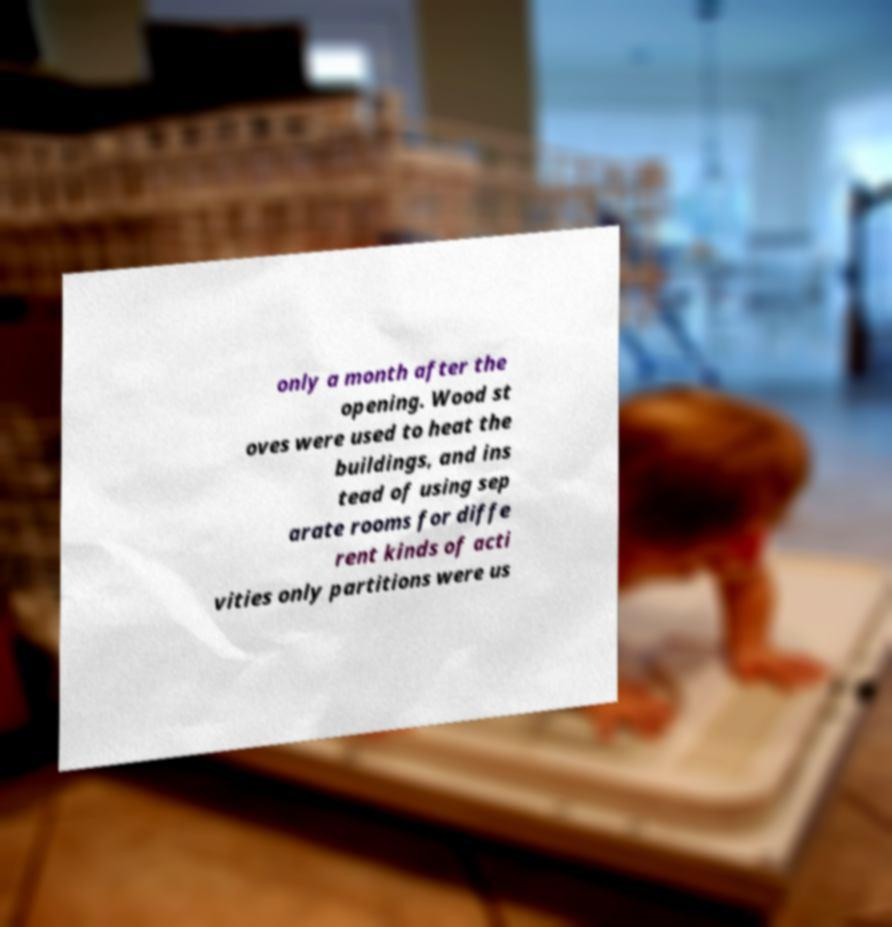Can you read and provide the text displayed in the image?This photo seems to have some interesting text. Can you extract and type it out for me? only a month after the opening. Wood st oves were used to heat the buildings, and ins tead of using sep arate rooms for diffe rent kinds of acti vities only partitions were us 